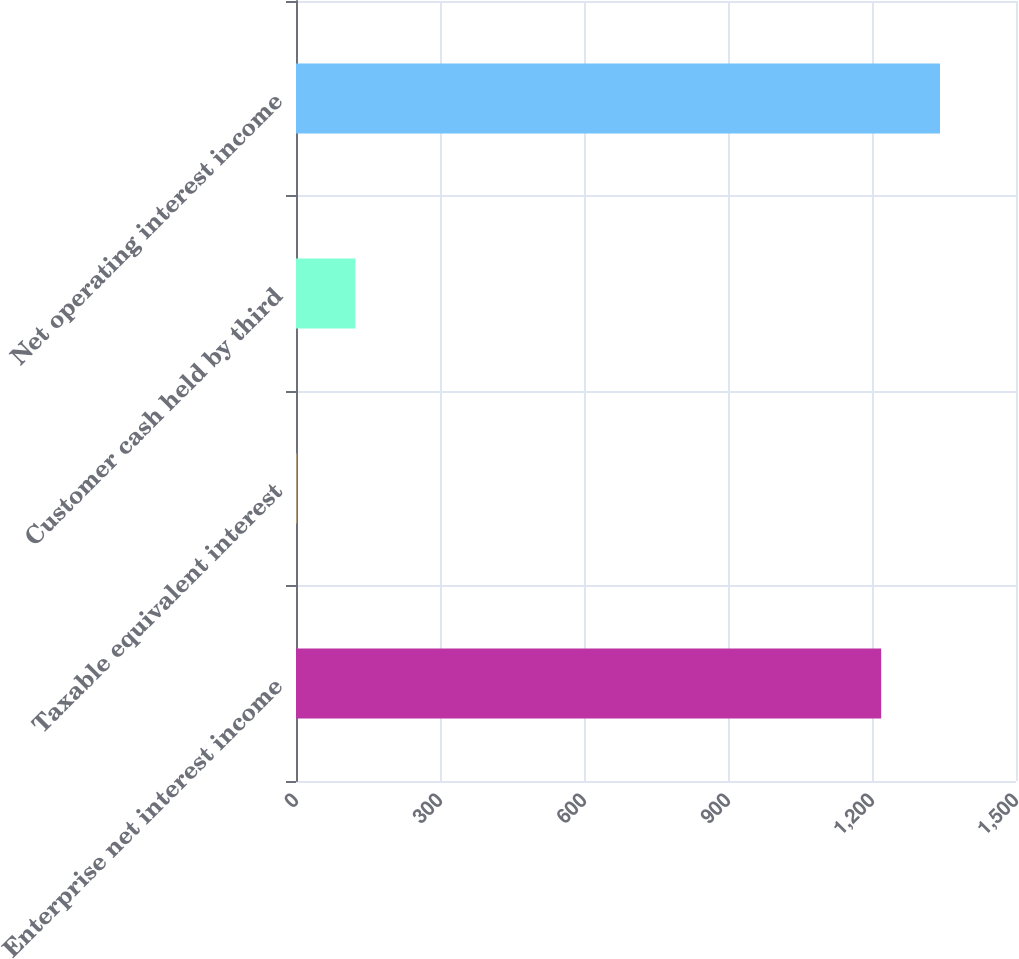Convert chart. <chart><loc_0><loc_0><loc_500><loc_500><bar_chart><fcel>Enterprise net interest income<fcel>Taxable equivalent interest<fcel>Customer cash held by third<fcel>Net operating interest income<nl><fcel>1219.1<fcel>1.2<fcel>123.71<fcel>1341.61<nl></chart> 